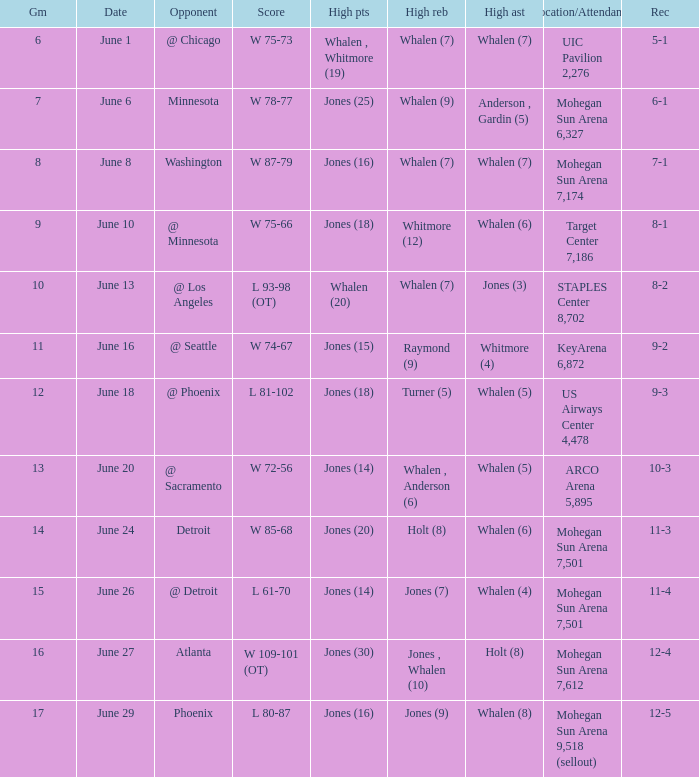What is the game on june 29? 17.0. 